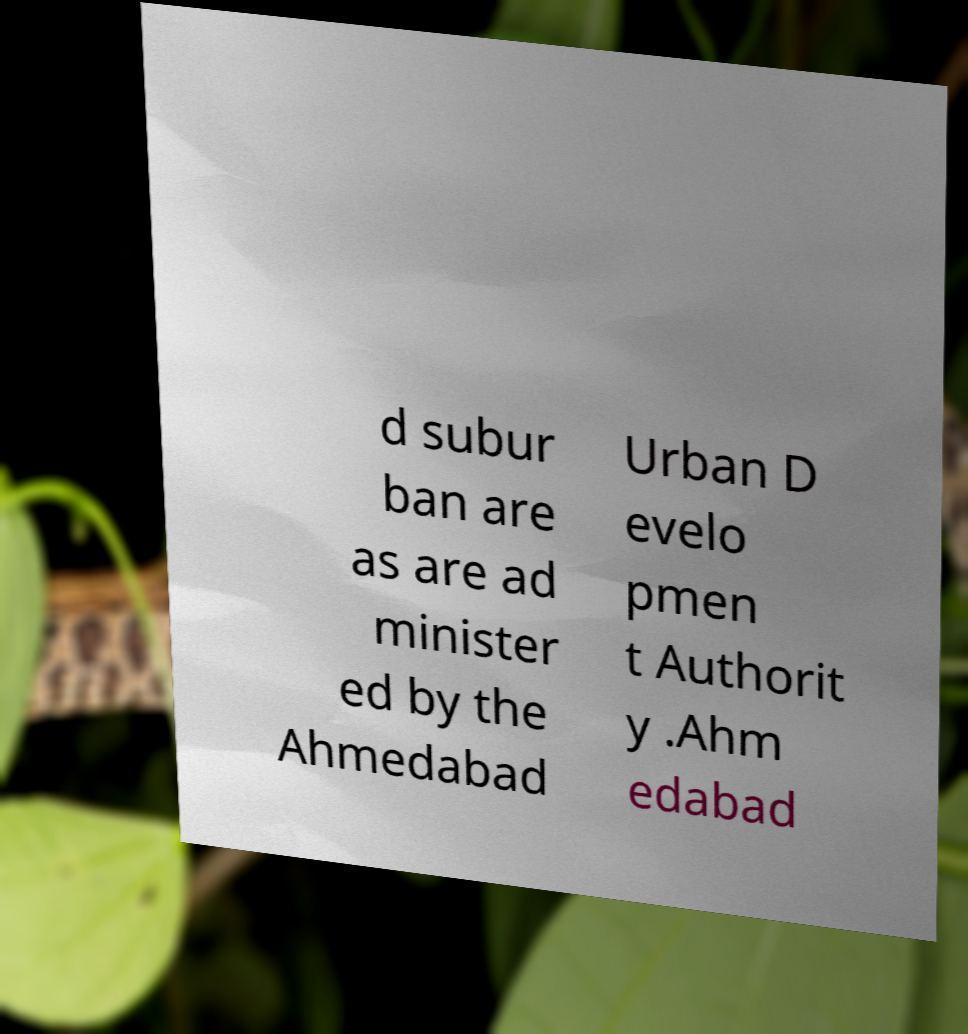Could you extract and type out the text from this image? d subur ban are as are ad minister ed by the Ahmedabad Urban D evelo pmen t Authorit y .Ahm edabad 